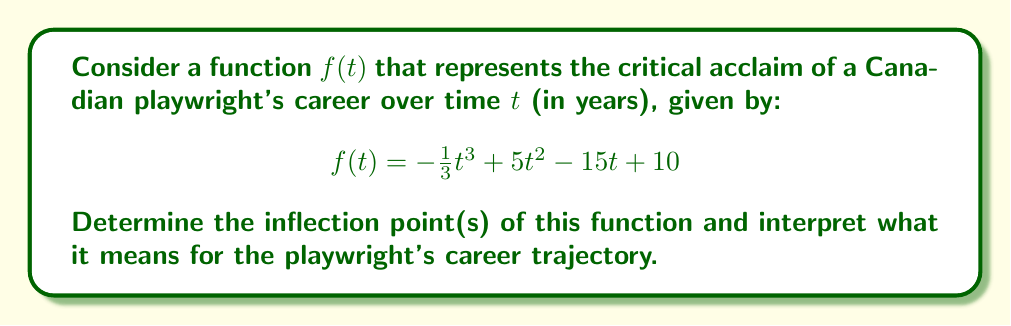Teach me how to tackle this problem. To find the inflection points of $f(t)$, we need to follow these steps:

1. Find the first derivative $f'(t)$:
   $$f'(t) = -t^2 + 10t - 15$$

2. Find the second derivative $f''(t)$:
   $$f''(t) = -2t + 10$$

3. Set $f''(t) = 0$ and solve for $t$:
   $$-2t + 10 = 0$$
   $$-2t = -10$$
   $$t = 5$$

4. Verify that $f''(t)$ changes sign at $t = 5$:
   $f''(4) = -2(4) + 10 = 2 > 0$
   $f''(6) = -2(6) + 10 = -2 < 0$

   Since $f''(t)$ changes from positive to negative at $t = 5$, this point is indeed an inflection point.

5. Calculate the corresponding $y$-coordinate:
   $$f(5) = -\frac{1}{3}(5^3) + 5(5^2) - 15(5) + 10 = -41.67 + 125 - 75 + 10 = 18.33$$

Interpretation:
The inflection point occurs at $(5, 18.33)$. This means that after 5 years in the playwright's career, there's a change in the rate of critical acclaim. Before this point, the rate of acclaim was increasing (concave up), and after this point, the rate of acclaim starts decreasing (concave down). This could represent a pivotal moment in the playwright's career where they've established themselves but may face new challenges in maintaining their rate of success.
Answer: The inflection point occurs at $(5, 18.33)$, representing a change in the playwright's career trajectory after 5 years, where the rate of critical acclaim shifts from increasing to decreasing. 